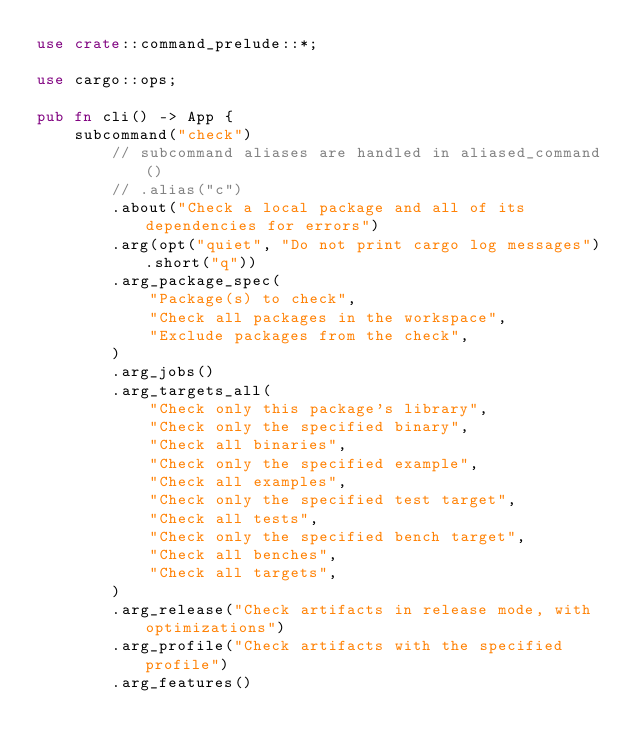<code> <loc_0><loc_0><loc_500><loc_500><_Rust_>use crate::command_prelude::*;

use cargo::ops;

pub fn cli() -> App {
    subcommand("check")
        // subcommand aliases are handled in aliased_command()
        // .alias("c")
        .about("Check a local package and all of its dependencies for errors")
        .arg(opt("quiet", "Do not print cargo log messages").short("q"))
        .arg_package_spec(
            "Package(s) to check",
            "Check all packages in the workspace",
            "Exclude packages from the check",
        )
        .arg_jobs()
        .arg_targets_all(
            "Check only this package's library",
            "Check only the specified binary",
            "Check all binaries",
            "Check only the specified example",
            "Check all examples",
            "Check only the specified test target",
            "Check all tests",
            "Check only the specified bench target",
            "Check all benches",
            "Check all targets",
        )
        .arg_release("Check artifacts in release mode, with optimizations")
        .arg_profile("Check artifacts with the specified profile")
        .arg_features()</code> 